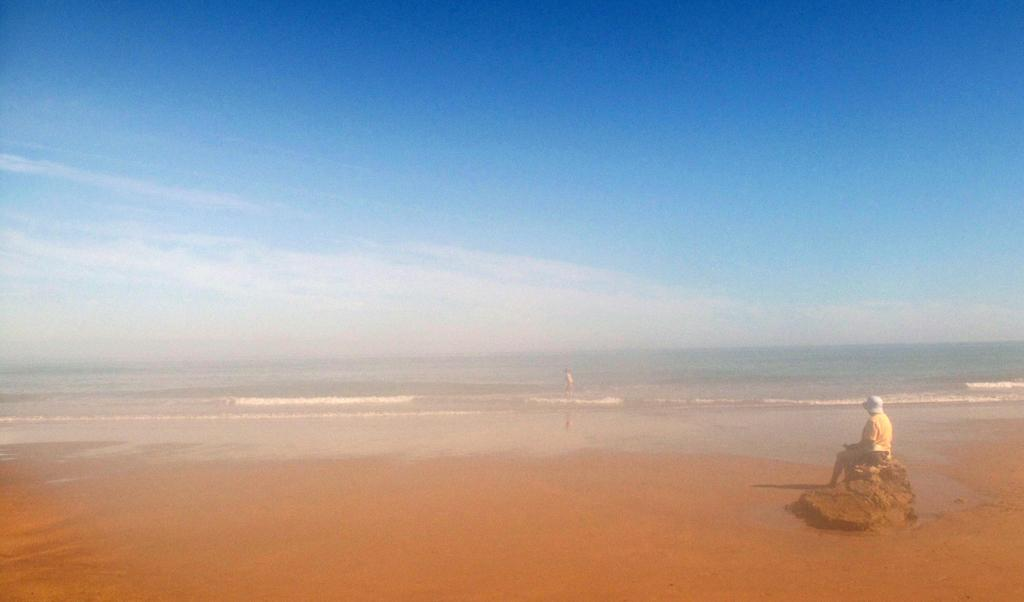Who or what is the main subject in the image? There is a person in the image. What is the person doing in the image? The person is sitting on a rock. Can you describe the location of the image? The location appears to be a seaside shore. What type of scarecrow can be seen standing near the person in the image? There is no scarecrow present in the image; it features a person sitting on a rock at a seaside shore. 